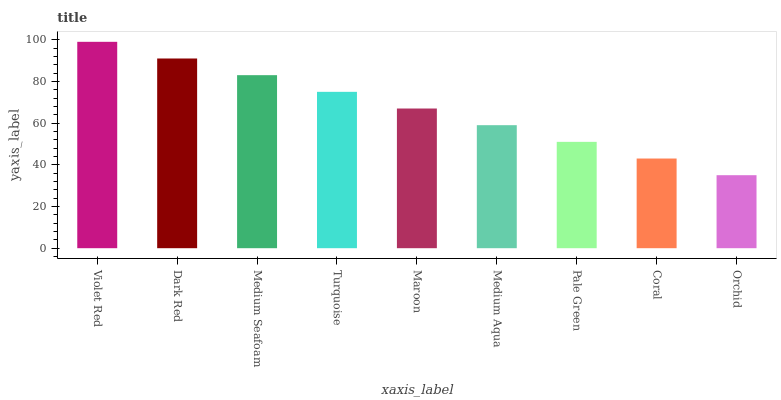Is Orchid the minimum?
Answer yes or no. Yes. Is Violet Red the maximum?
Answer yes or no. Yes. Is Dark Red the minimum?
Answer yes or no. No. Is Dark Red the maximum?
Answer yes or no. No. Is Violet Red greater than Dark Red?
Answer yes or no. Yes. Is Dark Red less than Violet Red?
Answer yes or no. Yes. Is Dark Red greater than Violet Red?
Answer yes or no. No. Is Violet Red less than Dark Red?
Answer yes or no. No. Is Maroon the high median?
Answer yes or no. Yes. Is Maroon the low median?
Answer yes or no. Yes. Is Medium Seafoam the high median?
Answer yes or no. No. Is Medium Aqua the low median?
Answer yes or no. No. 